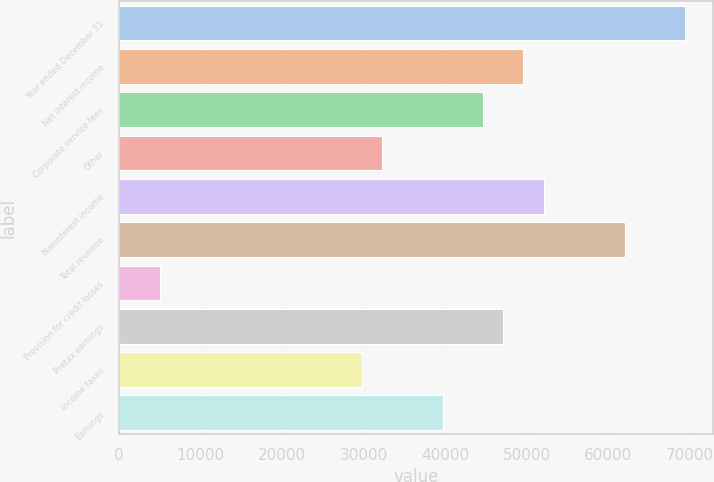<chart> <loc_0><loc_0><loc_500><loc_500><bar_chart><fcel>Year ended December 31<fcel>Net interest income<fcel>Corporate service fees<fcel>Other<fcel>Noninterest income<fcel>Total revenue<fcel>Provision for credit losses<fcel>Pretax earnings<fcel>Income taxes<fcel>Earnings<nl><fcel>69456.6<fcel>49619<fcel>44659.6<fcel>32261.1<fcel>52098.7<fcel>62017.5<fcel>4984.4<fcel>47139.3<fcel>29781.4<fcel>39700.2<nl></chart> 